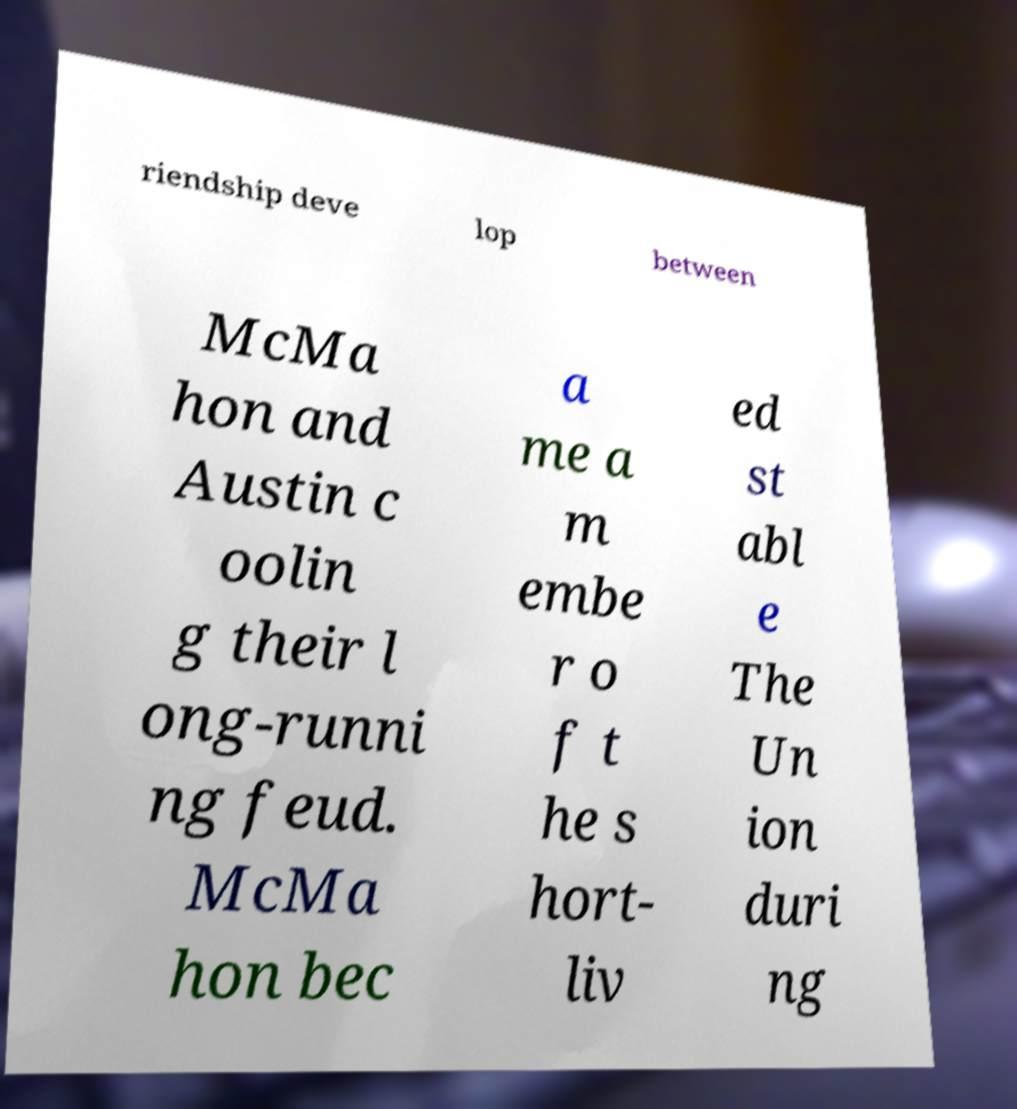Please read and relay the text visible in this image. What does it say? riendship deve lop between McMa hon and Austin c oolin g their l ong-runni ng feud. McMa hon bec a me a m embe r o f t he s hort- liv ed st abl e The Un ion duri ng 